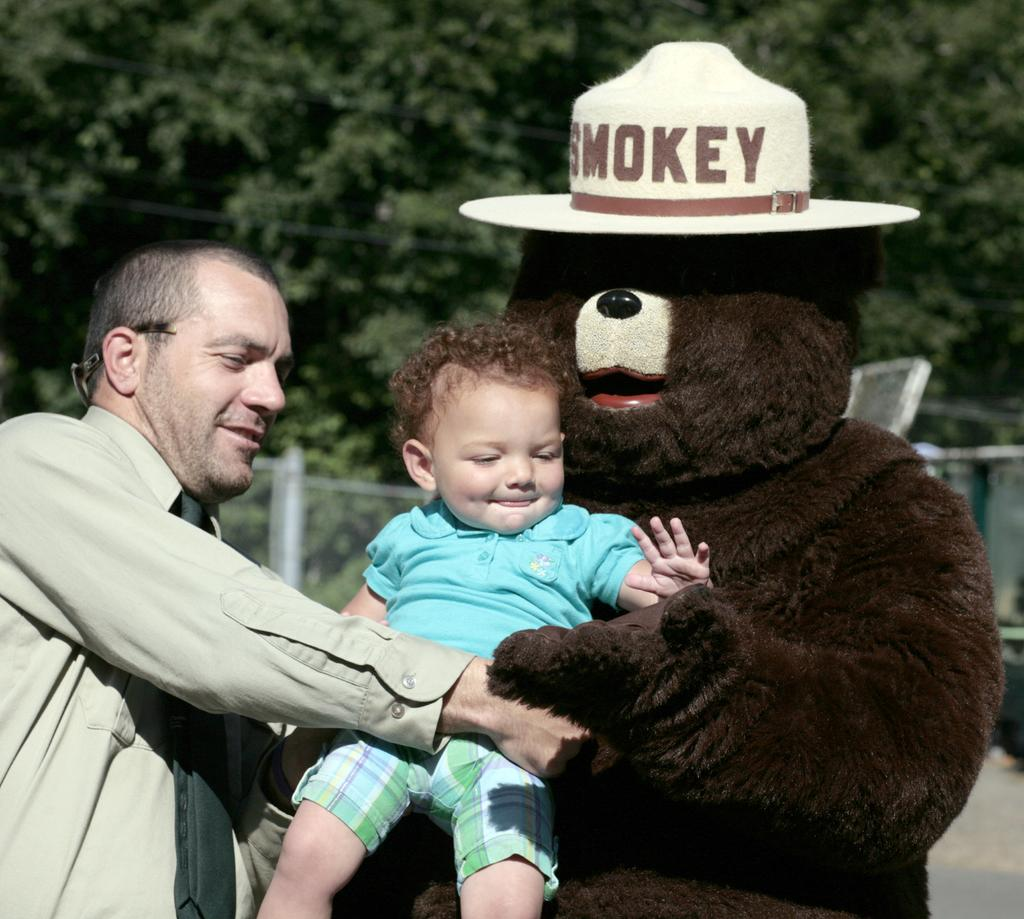Who is present in the image? There is a man and a kid in the image. What is the man doing in the image? The information provided does not specify what the man is doing. What can be seen on the right side of the image? There is a monkey costume on the right side of the image. What is visible in the background of the image? There are trees in the background of the image. Can you tell me how many bears are playing with the kitty in the image? There are no bears or kitties present in the image. 